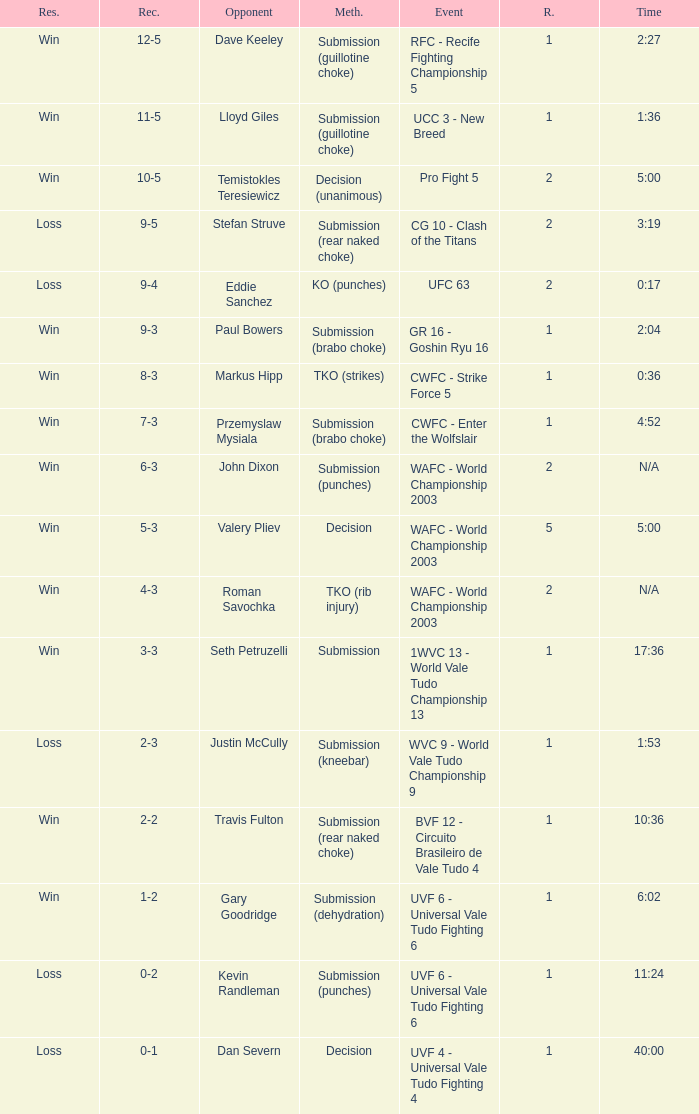What round has the highest Res loss, and a time of 40:00? 1.0. Write the full table. {'header': ['Res.', 'Rec.', 'Opponent', 'Meth.', 'Event', 'R.', 'Time'], 'rows': [['Win', '12-5', 'Dave Keeley', 'Submission (guillotine choke)', 'RFC - Recife Fighting Championship 5', '1', '2:27'], ['Win', '11-5', 'Lloyd Giles', 'Submission (guillotine choke)', 'UCC 3 - New Breed', '1', '1:36'], ['Win', '10-5', 'Temistokles Teresiewicz', 'Decision (unanimous)', 'Pro Fight 5', '2', '5:00'], ['Loss', '9-5', 'Stefan Struve', 'Submission (rear naked choke)', 'CG 10 - Clash of the Titans', '2', '3:19'], ['Loss', '9-4', 'Eddie Sanchez', 'KO (punches)', 'UFC 63', '2', '0:17'], ['Win', '9-3', 'Paul Bowers', 'Submission (brabo choke)', 'GR 16 - Goshin Ryu 16', '1', '2:04'], ['Win', '8-3', 'Markus Hipp', 'TKO (strikes)', 'CWFC - Strike Force 5', '1', '0:36'], ['Win', '7-3', 'Przemyslaw Mysiala', 'Submission (brabo choke)', 'CWFC - Enter the Wolfslair', '1', '4:52'], ['Win', '6-3', 'John Dixon', 'Submission (punches)', 'WAFC - World Championship 2003', '2', 'N/A'], ['Win', '5-3', 'Valery Pliev', 'Decision', 'WAFC - World Championship 2003', '5', '5:00'], ['Win', '4-3', 'Roman Savochka', 'TKO (rib injury)', 'WAFC - World Championship 2003', '2', 'N/A'], ['Win', '3-3', 'Seth Petruzelli', 'Submission', '1WVC 13 - World Vale Tudo Championship 13', '1', '17:36'], ['Loss', '2-3', 'Justin McCully', 'Submission (kneebar)', 'WVC 9 - World Vale Tudo Championship 9', '1', '1:53'], ['Win', '2-2', 'Travis Fulton', 'Submission (rear naked choke)', 'BVF 12 - Circuito Brasileiro de Vale Tudo 4', '1', '10:36'], ['Win', '1-2', 'Gary Goodridge', 'Submission (dehydration)', 'UVF 6 - Universal Vale Tudo Fighting 6', '1', '6:02'], ['Loss', '0-2', 'Kevin Randleman', 'Submission (punches)', 'UVF 6 - Universal Vale Tudo Fighting 6', '1', '11:24'], ['Loss', '0-1', 'Dan Severn', 'Decision', 'UVF 4 - Universal Vale Tudo Fighting 4', '1', '40:00']]} 